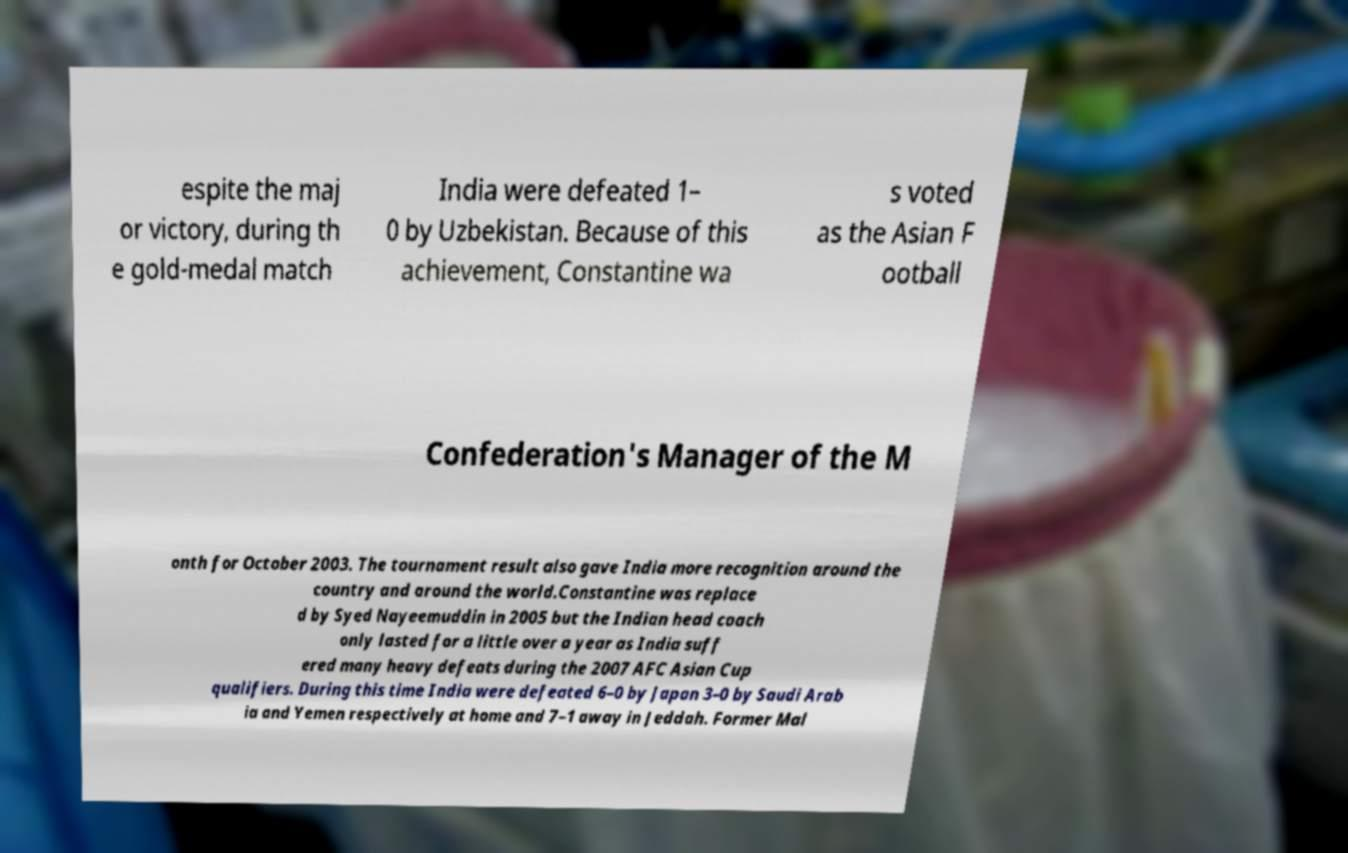There's text embedded in this image that I need extracted. Can you transcribe it verbatim? espite the maj or victory, during th e gold-medal match India were defeated 1– 0 by Uzbekistan. Because of this achievement, Constantine wa s voted as the Asian F ootball Confederation's Manager of the M onth for October 2003. The tournament result also gave India more recognition around the country and around the world.Constantine was replace d by Syed Nayeemuddin in 2005 but the Indian head coach only lasted for a little over a year as India suff ered many heavy defeats during the 2007 AFC Asian Cup qualifiers. During this time India were defeated 6–0 by Japan 3–0 by Saudi Arab ia and Yemen respectively at home and 7–1 away in Jeddah. Former Mal 